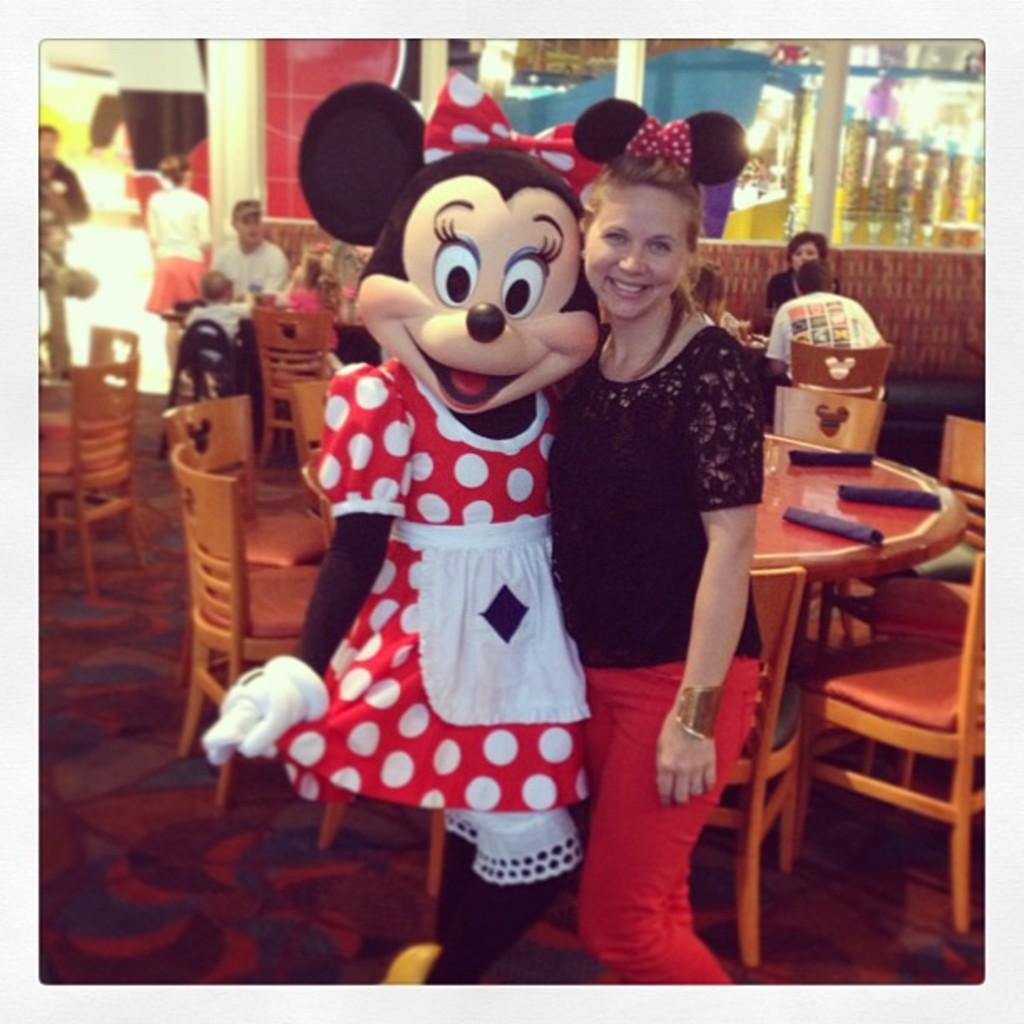Please provide a concise description of this image. In this image I see a woman and a mickey mouse and both of them are smiling. In the background I can see lot of chairs and tables and lot of people. 